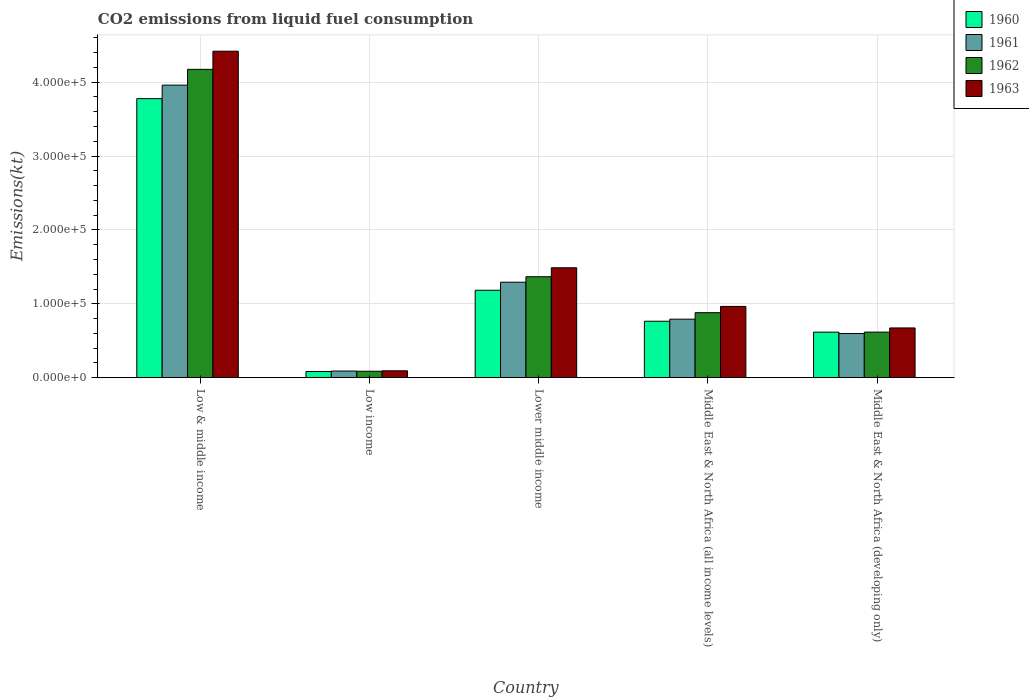How many different coloured bars are there?
Offer a very short reply. 4. Are the number of bars per tick equal to the number of legend labels?
Provide a succinct answer. Yes. How many bars are there on the 3rd tick from the left?
Your answer should be very brief. 4. How many bars are there on the 4th tick from the right?
Keep it short and to the point. 4. What is the label of the 4th group of bars from the left?
Give a very brief answer. Middle East & North Africa (all income levels). What is the amount of CO2 emitted in 1963 in Lower middle income?
Your response must be concise. 1.49e+05. Across all countries, what is the maximum amount of CO2 emitted in 1963?
Provide a succinct answer. 4.42e+05. Across all countries, what is the minimum amount of CO2 emitted in 1960?
Provide a short and direct response. 8381.5. In which country was the amount of CO2 emitted in 1963 maximum?
Give a very brief answer. Low & middle income. In which country was the amount of CO2 emitted in 1961 minimum?
Provide a short and direct response. Low income. What is the total amount of CO2 emitted in 1962 in the graph?
Give a very brief answer. 7.12e+05. What is the difference between the amount of CO2 emitted in 1961 in Low income and that in Lower middle income?
Provide a short and direct response. -1.20e+05. What is the difference between the amount of CO2 emitted in 1960 in Lower middle income and the amount of CO2 emitted in 1963 in Low & middle income?
Provide a succinct answer. -3.24e+05. What is the average amount of CO2 emitted in 1961 per country?
Provide a succinct answer. 1.35e+05. What is the difference between the amount of CO2 emitted of/in 1961 and amount of CO2 emitted of/in 1960 in Low & middle income?
Make the answer very short. 1.83e+04. In how many countries, is the amount of CO2 emitted in 1960 greater than 280000 kt?
Keep it short and to the point. 1. What is the ratio of the amount of CO2 emitted in 1961 in Low income to that in Middle East & North Africa (all income levels)?
Ensure brevity in your answer.  0.11. Is the difference between the amount of CO2 emitted in 1961 in Low & middle income and Lower middle income greater than the difference between the amount of CO2 emitted in 1960 in Low & middle income and Lower middle income?
Your answer should be very brief. Yes. What is the difference between the highest and the second highest amount of CO2 emitted in 1963?
Offer a terse response. -3.45e+05. What is the difference between the highest and the lowest amount of CO2 emitted in 1961?
Offer a terse response. 3.87e+05. Is it the case that in every country, the sum of the amount of CO2 emitted in 1960 and amount of CO2 emitted in 1962 is greater than the sum of amount of CO2 emitted in 1961 and amount of CO2 emitted in 1963?
Your answer should be very brief. No. What does the 3rd bar from the left in Middle East & North Africa (all income levels) represents?
Your answer should be very brief. 1962. What does the 1st bar from the right in Middle East & North Africa (all income levels) represents?
Your response must be concise. 1963. How many bars are there?
Provide a succinct answer. 20. How many countries are there in the graph?
Your answer should be compact. 5. What is the difference between two consecutive major ticks on the Y-axis?
Provide a short and direct response. 1.00e+05. Does the graph contain any zero values?
Offer a terse response. No. Does the graph contain grids?
Make the answer very short. Yes. Where does the legend appear in the graph?
Your answer should be very brief. Top right. How are the legend labels stacked?
Your answer should be compact. Vertical. What is the title of the graph?
Ensure brevity in your answer.  CO2 emissions from liquid fuel consumption. Does "1980" appear as one of the legend labels in the graph?
Your response must be concise. No. What is the label or title of the Y-axis?
Your answer should be very brief. Emissions(kt). What is the Emissions(kt) in 1960 in Low & middle income?
Make the answer very short. 3.78e+05. What is the Emissions(kt) of 1961 in Low & middle income?
Offer a terse response. 3.96e+05. What is the Emissions(kt) in 1962 in Low & middle income?
Offer a terse response. 4.17e+05. What is the Emissions(kt) of 1963 in Low & middle income?
Provide a succinct answer. 4.42e+05. What is the Emissions(kt) in 1960 in Low income?
Your response must be concise. 8381.5. What is the Emissions(kt) in 1961 in Low income?
Ensure brevity in your answer.  8977.1. What is the Emissions(kt) in 1962 in Low income?
Keep it short and to the point. 8722.53. What is the Emissions(kt) in 1963 in Low income?
Offer a terse response. 9280.81. What is the Emissions(kt) of 1960 in Lower middle income?
Your response must be concise. 1.18e+05. What is the Emissions(kt) in 1961 in Lower middle income?
Your answer should be compact. 1.29e+05. What is the Emissions(kt) of 1962 in Lower middle income?
Make the answer very short. 1.37e+05. What is the Emissions(kt) of 1963 in Lower middle income?
Offer a terse response. 1.49e+05. What is the Emissions(kt) of 1960 in Middle East & North Africa (all income levels)?
Give a very brief answer. 7.64e+04. What is the Emissions(kt) in 1961 in Middle East & North Africa (all income levels)?
Offer a terse response. 7.92e+04. What is the Emissions(kt) in 1962 in Middle East & North Africa (all income levels)?
Keep it short and to the point. 8.80e+04. What is the Emissions(kt) of 1963 in Middle East & North Africa (all income levels)?
Keep it short and to the point. 9.64e+04. What is the Emissions(kt) in 1960 in Middle East & North Africa (developing only)?
Offer a terse response. 6.16e+04. What is the Emissions(kt) in 1961 in Middle East & North Africa (developing only)?
Provide a short and direct response. 5.98e+04. What is the Emissions(kt) of 1962 in Middle East & North Africa (developing only)?
Keep it short and to the point. 6.17e+04. What is the Emissions(kt) in 1963 in Middle East & North Africa (developing only)?
Keep it short and to the point. 6.73e+04. Across all countries, what is the maximum Emissions(kt) of 1960?
Your answer should be very brief. 3.78e+05. Across all countries, what is the maximum Emissions(kt) in 1961?
Offer a very short reply. 3.96e+05. Across all countries, what is the maximum Emissions(kt) of 1962?
Provide a succinct answer. 4.17e+05. Across all countries, what is the maximum Emissions(kt) in 1963?
Give a very brief answer. 4.42e+05. Across all countries, what is the minimum Emissions(kt) of 1960?
Ensure brevity in your answer.  8381.5. Across all countries, what is the minimum Emissions(kt) of 1961?
Provide a short and direct response. 8977.1. Across all countries, what is the minimum Emissions(kt) of 1962?
Ensure brevity in your answer.  8722.53. Across all countries, what is the minimum Emissions(kt) in 1963?
Keep it short and to the point. 9280.81. What is the total Emissions(kt) in 1960 in the graph?
Give a very brief answer. 6.42e+05. What is the total Emissions(kt) in 1961 in the graph?
Provide a succinct answer. 6.73e+05. What is the total Emissions(kt) of 1962 in the graph?
Your response must be concise. 7.12e+05. What is the total Emissions(kt) in 1963 in the graph?
Provide a succinct answer. 7.64e+05. What is the difference between the Emissions(kt) of 1960 in Low & middle income and that in Low income?
Make the answer very short. 3.69e+05. What is the difference between the Emissions(kt) of 1961 in Low & middle income and that in Low income?
Provide a short and direct response. 3.87e+05. What is the difference between the Emissions(kt) in 1962 in Low & middle income and that in Low income?
Keep it short and to the point. 4.09e+05. What is the difference between the Emissions(kt) of 1963 in Low & middle income and that in Low income?
Make the answer very short. 4.33e+05. What is the difference between the Emissions(kt) in 1960 in Low & middle income and that in Lower middle income?
Your response must be concise. 2.59e+05. What is the difference between the Emissions(kt) in 1961 in Low & middle income and that in Lower middle income?
Provide a succinct answer. 2.67e+05. What is the difference between the Emissions(kt) in 1962 in Low & middle income and that in Lower middle income?
Make the answer very short. 2.81e+05. What is the difference between the Emissions(kt) in 1963 in Low & middle income and that in Lower middle income?
Ensure brevity in your answer.  2.93e+05. What is the difference between the Emissions(kt) of 1960 in Low & middle income and that in Middle East & North Africa (all income levels)?
Give a very brief answer. 3.01e+05. What is the difference between the Emissions(kt) of 1961 in Low & middle income and that in Middle East & North Africa (all income levels)?
Make the answer very short. 3.17e+05. What is the difference between the Emissions(kt) in 1962 in Low & middle income and that in Middle East & North Africa (all income levels)?
Make the answer very short. 3.29e+05. What is the difference between the Emissions(kt) in 1963 in Low & middle income and that in Middle East & North Africa (all income levels)?
Make the answer very short. 3.45e+05. What is the difference between the Emissions(kt) in 1960 in Low & middle income and that in Middle East & North Africa (developing only)?
Ensure brevity in your answer.  3.16e+05. What is the difference between the Emissions(kt) in 1961 in Low & middle income and that in Middle East & North Africa (developing only)?
Your answer should be compact. 3.36e+05. What is the difference between the Emissions(kt) of 1962 in Low & middle income and that in Middle East & North Africa (developing only)?
Your answer should be compact. 3.56e+05. What is the difference between the Emissions(kt) of 1963 in Low & middle income and that in Middle East & North Africa (developing only)?
Make the answer very short. 3.75e+05. What is the difference between the Emissions(kt) in 1960 in Low income and that in Lower middle income?
Provide a short and direct response. -1.10e+05. What is the difference between the Emissions(kt) in 1961 in Low income and that in Lower middle income?
Provide a short and direct response. -1.20e+05. What is the difference between the Emissions(kt) in 1962 in Low income and that in Lower middle income?
Provide a short and direct response. -1.28e+05. What is the difference between the Emissions(kt) of 1963 in Low income and that in Lower middle income?
Provide a succinct answer. -1.39e+05. What is the difference between the Emissions(kt) of 1960 in Low income and that in Middle East & North Africa (all income levels)?
Offer a terse response. -6.80e+04. What is the difference between the Emissions(kt) in 1961 in Low income and that in Middle East & North Africa (all income levels)?
Keep it short and to the point. -7.02e+04. What is the difference between the Emissions(kt) of 1962 in Low income and that in Middle East & North Africa (all income levels)?
Make the answer very short. -7.92e+04. What is the difference between the Emissions(kt) in 1963 in Low income and that in Middle East & North Africa (all income levels)?
Offer a very short reply. -8.72e+04. What is the difference between the Emissions(kt) of 1960 in Low income and that in Middle East & North Africa (developing only)?
Offer a terse response. -5.32e+04. What is the difference between the Emissions(kt) of 1961 in Low income and that in Middle East & North Africa (developing only)?
Keep it short and to the point. -5.08e+04. What is the difference between the Emissions(kt) of 1962 in Low income and that in Middle East & North Africa (developing only)?
Ensure brevity in your answer.  -5.30e+04. What is the difference between the Emissions(kt) of 1963 in Low income and that in Middle East & North Africa (developing only)?
Your answer should be compact. -5.80e+04. What is the difference between the Emissions(kt) in 1960 in Lower middle income and that in Middle East & North Africa (all income levels)?
Provide a succinct answer. 4.19e+04. What is the difference between the Emissions(kt) in 1961 in Lower middle income and that in Middle East & North Africa (all income levels)?
Keep it short and to the point. 5.00e+04. What is the difference between the Emissions(kt) of 1962 in Lower middle income and that in Middle East & North Africa (all income levels)?
Offer a terse response. 4.87e+04. What is the difference between the Emissions(kt) of 1963 in Lower middle income and that in Middle East & North Africa (all income levels)?
Give a very brief answer. 5.23e+04. What is the difference between the Emissions(kt) of 1960 in Lower middle income and that in Middle East & North Africa (developing only)?
Ensure brevity in your answer.  5.67e+04. What is the difference between the Emissions(kt) of 1961 in Lower middle income and that in Middle East & North Africa (developing only)?
Your answer should be very brief. 6.95e+04. What is the difference between the Emissions(kt) in 1962 in Lower middle income and that in Middle East & North Africa (developing only)?
Your answer should be compact. 7.49e+04. What is the difference between the Emissions(kt) of 1963 in Lower middle income and that in Middle East & North Africa (developing only)?
Give a very brief answer. 8.14e+04. What is the difference between the Emissions(kt) in 1960 in Middle East & North Africa (all income levels) and that in Middle East & North Africa (developing only)?
Your response must be concise. 1.48e+04. What is the difference between the Emissions(kt) of 1961 in Middle East & North Africa (all income levels) and that in Middle East & North Africa (developing only)?
Make the answer very short. 1.94e+04. What is the difference between the Emissions(kt) of 1962 in Middle East & North Africa (all income levels) and that in Middle East & North Africa (developing only)?
Ensure brevity in your answer.  2.63e+04. What is the difference between the Emissions(kt) in 1963 in Middle East & North Africa (all income levels) and that in Middle East & North Africa (developing only)?
Provide a succinct answer. 2.91e+04. What is the difference between the Emissions(kt) of 1960 in Low & middle income and the Emissions(kt) of 1961 in Low income?
Give a very brief answer. 3.69e+05. What is the difference between the Emissions(kt) of 1960 in Low & middle income and the Emissions(kt) of 1962 in Low income?
Your response must be concise. 3.69e+05. What is the difference between the Emissions(kt) of 1960 in Low & middle income and the Emissions(kt) of 1963 in Low income?
Your response must be concise. 3.68e+05. What is the difference between the Emissions(kt) of 1961 in Low & middle income and the Emissions(kt) of 1962 in Low income?
Ensure brevity in your answer.  3.87e+05. What is the difference between the Emissions(kt) in 1961 in Low & middle income and the Emissions(kt) in 1963 in Low income?
Offer a very short reply. 3.87e+05. What is the difference between the Emissions(kt) of 1962 in Low & middle income and the Emissions(kt) of 1963 in Low income?
Keep it short and to the point. 4.08e+05. What is the difference between the Emissions(kt) in 1960 in Low & middle income and the Emissions(kt) in 1961 in Lower middle income?
Your response must be concise. 2.48e+05. What is the difference between the Emissions(kt) in 1960 in Low & middle income and the Emissions(kt) in 1962 in Lower middle income?
Ensure brevity in your answer.  2.41e+05. What is the difference between the Emissions(kt) of 1960 in Low & middle income and the Emissions(kt) of 1963 in Lower middle income?
Offer a terse response. 2.29e+05. What is the difference between the Emissions(kt) of 1961 in Low & middle income and the Emissions(kt) of 1962 in Lower middle income?
Offer a very short reply. 2.59e+05. What is the difference between the Emissions(kt) of 1961 in Low & middle income and the Emissions(kt) of 1963 in Lower middle income?
Your answer should be compact. 2.47e+05. What is the difference between the Emissions(kt) in 1962 in Low & middle income and the Emissions(kt) in 1963 in Lower middle income?
Give a very brief answer. 2.69e+05. What is the difference between the Emissions(kt) of 1960 in Low & middle income and the Emissions(kt) of 1961 in Middle East & North Africa (all income levels)?
Keep it short and to the point. 2.98e+05. What is the difference between the Emissions(kt) of 1960 in Low & middle income and the Emissions(kt) of 1962 in Middle East & North Africa (all income levels)?
Offer a terse response. 2.90e+05. What is the difference between the Emissions(kt) of 1960 in Low & middle income and the Emissions(kt) of 1963 in Middle East & North Africa (all income levels)?
Give a very brief answer. 2.81e+05. What is the difference between the Emissions(kt) in 1961 in Low & middle income and the Emissions(kt) in 1962 in Middle East & North Africa (all income levels)?
Offer a very short reply. 3.08e+05. What is the difference between the Emissions(kt) of 1961 in Low & middle income and the Emissions(kt) of 1963 in Middle East & North Africa (all income levels)?
Offer a terse response. 2.99e+05. What is the difference between the Emissions(kt) of 1962 in Low & middle income and the Emissions(kt) of 1963 in Middle East & North Africa (all income levels)?
Ensure brevity in your answer.  3.21e+05. What is the difference between the Emissions(kt) of 1960 in Low & middle income and the Emissions(kt) of 1961 in Middle East & North Africa (developing only)?
Your answer should be very brief. 3.18e+05. What is the difference between the Emissions(kt) in 1960 in Low & middle income and the Emissions(kt) in 1962 in Middle East & North Africa (developing only)?
Make the answer very short. 3.16e+05. What is the difference between the Emissions(kt) in 1960 in Low & middle income and the Emissions(kt) in 1963 in Middle East & North Africa (developing only)?
Your response must be concise. 3.10e+05. What is the difference between the Emissions(kt) of 1961 in Low & middle income and the Emissions(kt) of 1962 in Middle East & North Africa (developing only)?
Give a very brief answer. 3.34e+05. What is the difference between the Emissions(kt) in 1961 in Low & middle income and the Emissions(kt) in 1963 in Middle East & North Africa (developing only)?
Your response must be concise. 3.29e+05. What is the difference between the Emissions(kt) in 1962 in Low & middle income and the Emissions(kt) in 1963 in Middle East & North Africa (developing only)?
Give a very brief answer. 3.50e+05. What is the difference between the Emissions(kt) of 1960 in Low income and the Emissions(kt) of 1961 in Lower middle income?
Your answer should be compact. -1.21e+05. What is the difference between the Emissions(kt) of 1960 in Low income and the Emissions(kt) of 1962 in Lower middle income?
Make the answer very short. -1.28e+05. What is the difference between the Emissions(kt) in 1960 in Low income and the Emissions(kt) in 1963 in Lower middle income?
Your response must be concise. -1.40e+05. What is the difference between the Emissions(kt) in 1961 in Low income and the Emissions(kt) in 1962 in Lower middle income?
Offer a very short reply. -1.28e+05. What is the difference between the Emissions(kt) of 1961 in Low income and the Emissions(kt) of 1963 in Lower middle income?
Provide a short and direct response. -1.40e+05. What is the difference between the Emissions(kt) of 1962 in Low income and the Emissions(kt) of 1963 in Lower middle income?
Keep it short and to the point. -1.40e+05. What is the difference between the Emissions(kt) in 1960 in Low income and the Emissions(kt) in 1961 in Middle East & North Africa (all income levels)?
Provide a short and direct response. -7.08e+04. What is the difference between the Emissions(kt) of 1960 in Low income and the Emissions(kt) of 1962 in Middle East & North Africa (all income levels)?
Provide a short and direct response. -7.96e+04. What is the difference between the Emissions(kt) of 1960 in Low income and the Emissions(kt) of 1963 in Middle East & North Africa (all income levels)?
Provide a short and direct response. -8.81e+04. What is the difference between the Emissions(kt) of 1961 in Low income and the Emissions(kt) of 1962 in Middle East & North Africa (all income levels)?
Offer a very short reply. -7.90e+04. What is the difference between the Emissions(kt) in 1961 in Low income and the Emissions(kt) in 1963 in Middle East & North Africa (all income levels)?
Provide a succinct answer. -8.75e+04. What is the difference between the Emissions(kt) in 1962 in Low income and the Emissions(kt) in 1963 in Middle East & North Africa (all income levels)?
Keep it short and to the point. -8.77e+04. What is the difference between the Emissions(kt) in 1960 in Low income and the Emissions(kt) in 1961 in Middle East & North Africa (developing only)?
Your answer should be compact. -5.14e+04. What is the difference between the Emissions(kt) of 1960 in Low income and the Emissions(kt) of 1962 in Middle East & North Africa (developing only)?
Your answer should be very brief. -5.33e+04. What is the difference between the Emissions(kt) of 1960 in Low income and the Emissions(kt) of 1963 in Middle East & North Africa (developing only)?
Give a very brief answer. -5.89e+04. What is the difference between the Emissions(kt) of 1961 in Low income and the Emissions(kt) of 1962 in Middle East & North Africa (developing only)?
Provide a short and direct response. -5.27e+04. What is the difference between the Emissions(kt) of 1961 in Low income and the Emissions(kt) of 1963 in Middle East & North Africa (developing only)?
Your response must be concise. -5.83e+04. What is the difference between the Emissions(kt) of 1962 in Low income and the Emissions(kt) of 1963 in Middle East & North Africa (developing only)?
Your response must be concise. -5.86e+04. What is the difference between the Emissions(kt) of 1960 in Lower middle income and the Emissions(kt) of 1961 in Middle East & North Africa (all income levels)?
Keep it short and to the point. 3.91e+04. What is the difference between the Emissions(kt) of 1960 in Lower middle income and the Emissions(kt) of 1962 in Middle East & North Africa (all income levels)?
Provide a succinct answer. 3.03e+04. What is the difference between the Emissions(kt) in 1960 in Lower middle income and the Emissions(kt) in 1963 in Middle East & North Africa (all income levels)?
Offer a very short reply. 2.19e+04. What is the difference between the Emissions(kt) in 1961 in Lower middle income and the Emissions(kt) in 1962 in Middle East & North Africa (all income levels)?
Offer a very short reply. 4.13e+04. What is the difference between the Emissions(kt) of 1961 in Lower middle income and the Emissions(kt) of 1963 in Middle East & North Africa (all income levels)?
Provide a short and direct response. 3.28e+04. What is the difference between the Emissions(kt) of 1962 in Lower middle income and the Emissions(kt) of 1963 in Middle East & North Africa (all income levels)?
Provide a succinct answer. 4.02e+04. What is the difference between the Emissions(kt) in 1960 in Lower middle income and the Emissions(kt) in 1961 in Middle East & North Africa (developing only)?
Provide a succinct answer. 5.85e+04. What is the difference between the Emissions(kt) of 1960 in Lower middle income and the Emissions(kt) of 1962 in Middle East & North Africa (developing only)?
Your response must be concise. 5.66e+04. What is the difference between the Emissions(kt) of 1960 in Lower middle income and the Emissions(kt) of 1963 in Middle East & North Africa (developing only)?
Provide a succinct answer. 5.10e+04. What is the difference between the Emissions(kt) of 1961 in Lower middle income and the Emissions(kt) of 1962 in Middle East & North Africa (developing only)?
Ensure brevity in your answer.  6.75e+04. What is the difference between the Emissions(kt) of 1961 in Lower middle income and the Emissions(kt) of 1963 in Middle East & North Africa (developing only)?
Give a very brief answer. 6.19e+04. What is the difference between the Emissions(kt) in 1962 in Lower middle income and the Emissions(kt) in 1963 in Middle East & North Africa (developing only)?
Ensure brevity in your answer.  6.93e+04. What is the difference between the Emissions(kt) of 1960 in Middle East & North Africa (all income levels) and the Emissions(kt) of 1961 in Middle East & North Africa (developing only)?
Your answer should be very brief. 1.66e+04. What is the difference between the Emissions(kt) in 1960 in Middle East & North Africa (all income levels) and the Emissions(kt) in 1962 in Middle East & North Africa (developing only)?
Keep it short and to the point. 1.47e+04. What is the difference between the Emissions(kt) in 1960 in Middle East & North Africa (all income levels) and the Emissions(kt) in 1963 in Middle East & North Africa (developing only)?
Offer a terse response. 9054.3. What is the difference between the Emissions(kt) in 1961 in Middle East & North Africa (all income levels) and the Emissions(kt) in 1962 in Middle East & North Africa (developing only)?
Provide a succinct answer. 1.75e+04. What is the difference between the Emissions(kt) of 1961 in Middle East & North Africa (all income levels) and the Emissions(kt) of 1963 in Middle East & North Africa (developing only)?
Offer a very short reply. 1.19e+04. What is the difference between the Emissions(kt) of 1962 in Middle East & North Africa (all income levels) and the Emissions(kt) of 1963 in Middle East & North Africa (developing only)?
Your response must be concise. 2.07e+04. What is the average Emissions(kt) in 1960 per country?
Your answer should be very brief. 1.28e+05. What is the average Emissions(kt) in 1961 per country?
Offer a very short reply. 1.35e+05. What is the average Emissions(kt) of 1962 per country?
Your response must be concise. 1.42e+05. What is the average Emissions(kt) in 1963 per country?
Offer a very short reply. 1.53e+05. What is the difference between the Emissions(kt) of 1960 and Emissions(kt) of 1961 in Low & middle income?
Your answer should be very brief. -1.83e+04. What is the difference between the Emissions(kt) in 1960 and Emissions(kt) in 1962 in Low & middle income?
Offer a terse response. -3.96e+04. What is the difference between the Emissions(kt) in 1960 and Emissions(kt) in 1963 in Low & middle income?
Offer a very short reply. -6.42e+04. What is the difference between the Emissions(kt) in 1961 and Emissions(kt) in 1962 in Low & middle income?
Make the answer very short. -2.14e+04. What is the difference between the Emissions(kt) of 1961 and Emissions(kt) of 1963 in Low & middle income?
Provide a succinct answer. -4.59e+04. What is the difference between the Emissions(kt) in 1962 and Emissions(kt) in 1963 in Low & middle income?
Keep it short and to the point. -2.46e+04. What is the difference between the Emissions(kt) in 1960 and Emissions(kt) in 1961 in Low income?
Keep it short and to the point. -595.59. What is the difference between the Emissions(kt) in 1960 and Emissions(kt) in 1962 in Low income?
Your answer should be compact. -341.02. What is the difference between the Emissions(kt) in 1960 and Emissions(kt) in 1963 in Low income?
Your response must be concise. -899.3. What is the difference between the Emissions(kt) in 1961 and Emissions(kt) in 1962 in Low income?
Your response must be concise. 254.57. What is the difference between the Emissions(kt) of 1961 and Emissions(kt) of 1963 in Low income?
Offer a very short reply. -303.71. What is the difference between the Emissions(kt) of 1962 and Emissions(kt) of 1963 in Low income?
Offer a very short reply. -558.28. What is the difference between the Emissions(kt) of 1960 and Emissions(kt) of 1961 in Lower middle income?
Provide a succinct answer. -1.09e+04. What is the difference between the Emissions(kt) of 1960 and Emissions(kt) of 1962 in Lower middle income?
Your answer should be very brief. -1.83e+04. What is the difference between the Emissions(kt) in 1960 and Emissions(kt) in 1963 in Lower middle income?
Provide a short and direct response. -3.04e+04. What is the difference between the Emissions(kt) of 1961 and Emissions(kt) of 1962 in Lower middle income?
Provide a succinct answer. -7400.19. What is the difference between the Emissions(kt) of 1961 and Emissions(kt) of 1963 in Lower middle income?
Ensure brevity in your answer.  -1.95e+04. What is the difference between the Emissions(kt) in 1962 and Emissions(kt) in 1963 in Lower middle income?
Ensure brevity in your answer.  -1.21e+04. What is the difference between the Emissions(kt) in 1960 and Emissions(kt) in 1961 in Middle East & North Africa (all income levels)?
Provide a short and direct response. -2824.83. What is the difference between the Emissions(kt) of 1960 and Emissions(kt) of 1962 in Middle East & North Africa (all income levels)?
Offer a terse response. -1.16e+04. What is the difference between the Emissions(kt) of 1960 and Emissions(kt) of 1963 in Middle East & North Africa (all income levels)?
Offer a very short reply. -2.01e+04. What is the difference between the Emissions(kt) of 1961 and Emissions(kt) of 1962 in Middle East & North Africa (all income levels)?
Your answer should be compact. -8782.71. What is the difference between the Emissions(kt) in 1961 and Emissions(kt) in 1963 in Middle East & North Africa (all income levels)?
Provide a succinct answer. -1.73e+04. What is the difference between the Emissions(kt) of 1962 and Emissions(kt) of 1963 in Middle East & North Africa (all income levels)?
Give a very brief answer. -8470.85. What is the difference between the Emissions(kt) of 1960 and Emissions(kt) of 1961 in Middle East & North Africa (developing only)?
Give a very brief answer. 1849.85. What is the difference between the Emissions(kt) of 1960 and Emissions(kt) of 1962 in Middle East & North Africa (developing only)?
Make the answer very short. -69.74. What is the difference between the Emissions(kt) of 1960 and Emissions(kt) of 1963 in Middle East & North Africa (developing only)?
Provide a short and direct response. -5696.37. What is the difference between the Emissions(kt) in 1961 and Emissions(kt) in 1962 in Middle East & North Africa (developing only)?
Make the answer very short. -1919.59. What is the difference between the Emissions(kt) in 1961 and Emissions(kt) in 1963 in Middle East & North Africa (developing only)?
Provide a succinct answer. -7546.22. What is the difference between the Emissions(kt) of 1962 and Emissions(kt) of 1963 in Middle East & North Africa (developing only)?
Offer a very short reply. -5626.64. What is the ratio of the Emissions(kt) in 1960 in Low & middle income to that in Low income?
Make the answer very short. 45.06. What is the ratio of the Emissions(kt) in 1961 in Low & middle income to that in Low income?
Provide a succinct answer. 44.1. What is the ratio of the Emissions(kt) in 1962 in Low & middle income to that in Low income?
Give a very brief answer. 47.84. What is the ratio of the Emissions(kt) of 1963 in Low & middle income to that in Low income?
Your answer should be compact. 47.61. What is the ratio of the Emissions(kt) of 1960 in Low & middle income to that in Lower middle income?
Your response must be concise. 3.19. What is the ratio of the Emissions(kt) of 1961 in Low & middle income to that in Lower middle income?
Provide a short and direct response. 3.06. What is the ratio of the Emissions(kt) in 1962 in Low & middle income to that in Lower middle income?
Your answer should be very brief. 3.05. What is the ratio of the Emissions(kt) in 1963 in Low & middle income to that in Lower middle income?
Keep it short and to the point. 2.97. What is the ratio of the Emissions(kt) in 1960 in Low & middle income to that in Middle East & North Africa (all income levels)?
Your response must be concise. 4.95. What is the ratio of the Emissions(kt) in 1961 in Low & middle income to that in Middle East & North Africa (all income levels)?
Your answer should be very brief. 5. What is the ratio of the Emissions(kt) of 1962 in Low & middle income to that in Middle East & North Africa (all income levels)?
Your answer should be compact. 4.74. What is the ratio of the Emissions(kt) of 1963 in Low & middle income to that in Middle East & North Africa (all income levels)?
Offer a terse response. 4.58. What is the ratio of the Emissions(kt) in 1960 in Low & middle income to that in Middle East & North Africa (developing only)?
Make the answer very short. 6.13. What is the ratio of the Emissions(kt) in 1961 in Low & middle income to that in Middle East & North Africa (developing only)?
Ensure brevity in your answer.  6.63. What is the ratio of the Emissions(kt) of 1962 in Low & middle income to that in Middle East & North Africa (developing only)?
Make the answer very short. 6.77. What is the ratio of the Emissions(kt) in 1963 in Low & middle income to that in Middle East & North Africa (developing only)?
Offer a very short reply. 6.57. What is the ratio of the Emissions(kt) in 1960 in Low income to that in Lower middle income?
Provide a succinct answer. 0.07. What is the ratio of the Emissions(kt) in 1961 in Low income to that in Lower middle income?
Ensure brevity in your answer.  0.07. What is the ratio of the Emissions(kt) of 1962 in Low income to that in Lower middle income?
Provide a succinct answer. 0.06. What is the ratio of the Emissions(kt) of 1963 in Low income to that in Lower middle income?
Offer a terse response. 0.06. What is the ratio of the Emissions(kt) of 1960 in Low income to that in Middle East & North Africa (all income levels)?
Offer a terse response. 0.11. What is the ratio of the Emissions(kt) in 1961 in Low income to that in Middle East & North Africa (all income levels)?
Your answer should be very brief. 0.11. What is the ratio of the Emissions(kt) of 1962 in Low income to that in Middle East & North Africa (all income levels)?
Your response must be concise. 0.1. What is the ratio of the Emissions(kt) in 1963 in Low income to that in Middle East & North Africa (all income levels)?
Provide a short and direct response. 0.1. What is the ratio of the Emissions(kt) in 1960 in Low income to that in Middle East & North Africa (developing only)?
Make the answer very short. 0.14. What is the ratio of the Emissions(kt) in 1961 in Low income to that in Middle East & North Africa (developing only)?
Ensure brevity in your answer.  0.15. What is the ratio of the Emissions(kt) in 1962 in Low income to that in Middle East & North Africa (developing only)?
Provide a succinct answer. 0.14. What is the ratio of the Emissions(kt) of 1963 in Low income to that in Middle East & North Africa (developing only)?
Keep it short and to the point. 0.14. What is the ratio of the Emissions(kt) of 1960 in Lower middle income to that in Middle East & North Africa (all income levels)?
Offer a terse response. 1.55. What is the ratio of the Emissions(kt) of 1961 in Lower middle income to that in Middle East & North Africa (all income levels)?
Keep it short and to the point. 1.63. What is the ratio of the Emissions(kt) of 1962 in Lower middle income to that in Middle East & North Africa (all income levels)?
Your response must be concise. 1.55. What is the ratio of the Emissions(kt) of 1963 in Lower middle income to that in Middle East & North Africa (all income levels)?
Keep it short and to the point. 1.54. What is the ratio of the Emissions(kt) in 1960 in Lower middle income to that in Middle East & North Africa (developing only)?
Your answer should be compact. 1.92. What is the ratio of the Emissions(kt) of 1961 in Lower middle income to that in Middle East & North Africa (developing only)?
Your answer should be compact. 2.16. What is the ratio of the Emissions(kt) of 1962 in Lower middle income to that in Middle East & North Africa (developing only)?
Make the answer very short. 2.22. What is the ratio of the Emissions(kt) in 1963 in Lower middle income to that in Middle East & North Africa (developing only)?
Provide a succinct answer. 2.21. What is the ratio of the Emissions(kt) in 1960 in Middle East & North Africa (all income levels) to that in Middle East & North Africa (developing only)?
Make the answer very short. 1.24. What is the ratio of the Emissions(kt) of 1961 in Middle East & North Africa (all income levels) to that in Middle East & North Africa (developing only)?
Offer a very short reply. 1.33. What is the ratio of the Emissions(kt) in 1962 in Middle East & North Africa (all income levels) to that in Middle East & North Africa (developing only)?
Offer a very short reply. 1.43. What is the ratio of the Emissions(kt) in 1963 in Middle East & North Africa (all income levels) to that in Middle East & North Africa (developing only)?
Your answer should be very brief. 1.43. What is the difference between the highest and the second highest Emissions(kt) in 1960?
Provide a short and direct response. 2.59e+05. What is the difference between the highest and the second highest Emissions(kt) of 1961?
Your answer should be compact. 2.67e+05. What is the difference between the highest and the second highest Emissions(kt) in 1962?
Make the answer very short. 2.81e+05. What is the difference between the highest and the second highest Emissions(kt) in 1963?
Make the answer very short. 2.93e+05. What is the difference between the highest and the lowest Emissions(kt) of 1960?
Make the answer very short. 3.69e+05. What is the difference between the highest and the lowest Emissions(kt) in 1961?
Ensure brevity in your answer.  3.87e+05. What is the difference between the highest and the lowest Emissions(kt) in 1962?
Make the answer very short. 4.09e+05. What is the difference between the highest and the lowest Emissions(kt) in 1963?
Keep it short and to the point. 4.33e+05. 